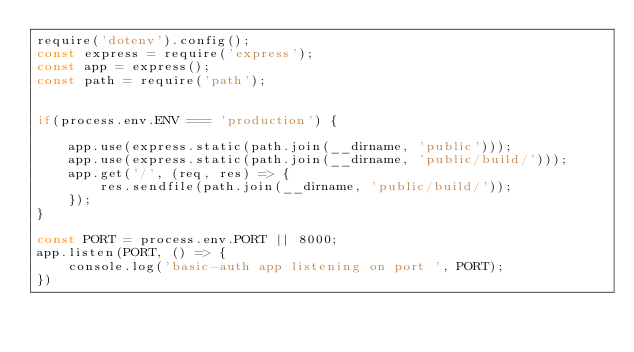<code> <loc_0><loc_0><loc_500><loc_500><_JavaScript_>require('dotenv').config();
const express = require('express');
const app = express();
const path = require('path');


if(process.env.ENV === 'production') {
    
    app.use(express.static(path.join(__dirname, 'public')));
    app.use(express.static(path.join(__dirname, 'public/build/')));    
    app.get('/', (req, res) => {
        res.sendfile(path.join(__dirname, 'public/build/'));
    });    
}

const PORT = process.env.PORT || 8000;
app.listen(PORT, () => {
    console.log('basic-auth app listening on port ', PORT);
})</code> 